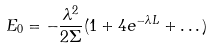<formula> <loc_0><loc_0><loc_500><loc_500>E _ { 0 } = - \frac { \lambda ^ { 2 } } { 2 \Sigma } ( 1 + 4 e ^ { - \lambda L } + \dots )</formula> 